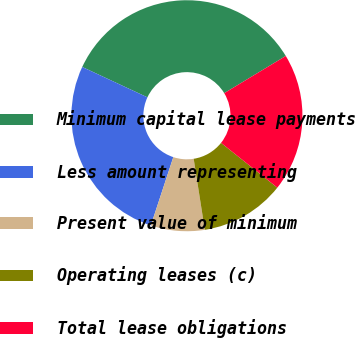Convert chart. <chart><loc_0><loc_0><loc_500><loc_500><pie_chart><fcel>Minimum capital lease payments<fcel>Less amount representing<fcel>Present value of minimum<fcel>Operating leases (c)<fcel>Total lease obligations<nl><fcel>34.41%<fcel>26.88%<fcel>7.53%<fcel>11.83%<fcel>19.35%<nl></chart> 